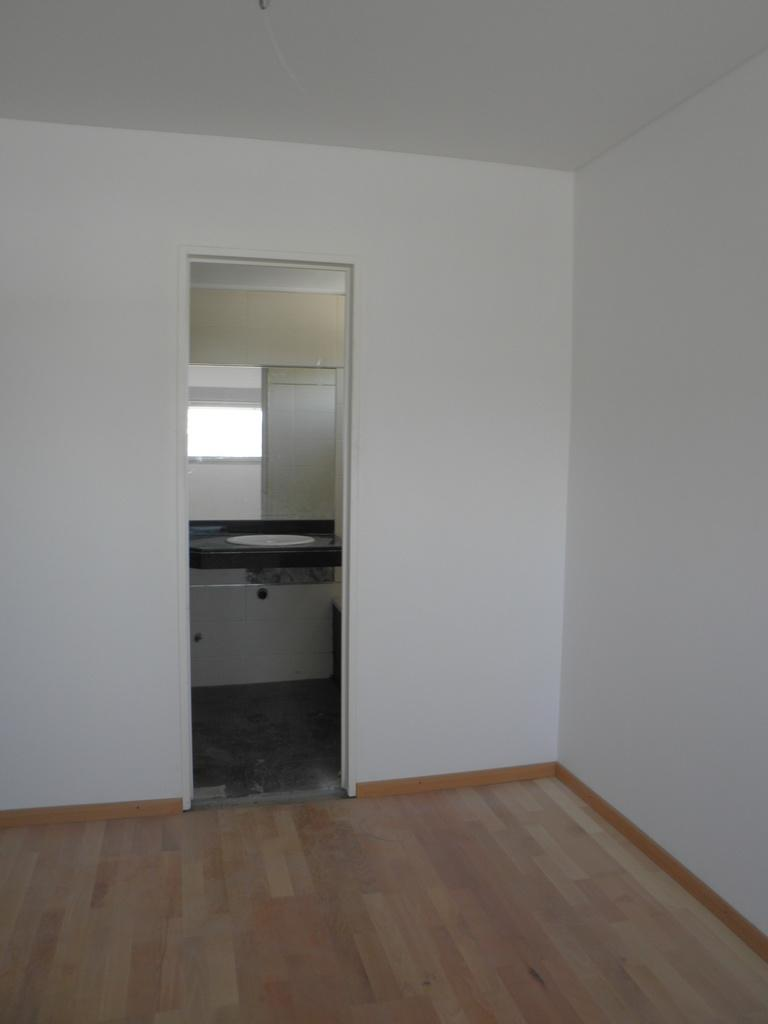What type of space is depicted in the image? The image shows an inside view of a room. What color is the wall in the room? The wall in the room is white. Can you describe any architectural features in the room? A window is visible in the middle of the room. What type of cushion is being used for the haircut in the image? There is no haircut or cushion present in the image; it shows an inside view of a room with a white wall and a window. 